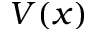<formula> <loc_0><loc_0><loc_500><loc_500>V ( x )</formula> 